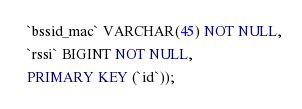<code> <loc_0><loc_0><loc_500><loc_500><_SQL_>  `bssid_mac` VARCHAR(45) NOT NULL,
  `rssi` BIGINT NOT NULL,
  PRIMARY KEY (`id`));</code> 